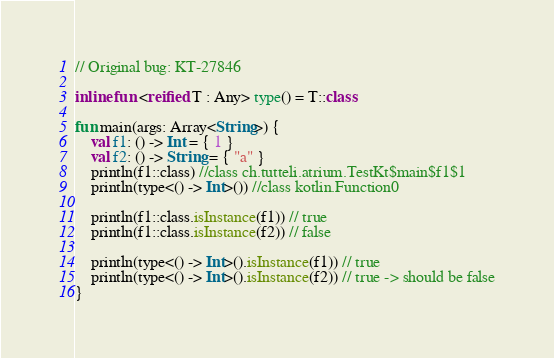Convert code to text. <code><loc_0><loc_0><loc_500><loc_500><_Kotlin_>// Original bug: KT-27846

inline fun <reified T : Any> type() = T::class

fun main(args: Array<String>) {
    val f1: () -> Int = { 1 }
    val f2: () -> String = { "a" }
    println(f1::class) //class ch.tutteli.atrium.TestKt$main$f1$1
    println(type<() -> Int>()) //class kotlin.Function0

    println(f1::class.isInstance(f1)) // true
    println(f1::class.isInstance(f2)) // false

    println(type<() -> Int>().isInstance(f1)) // true
    println(type<() -> Int>().isInstance(f2)) // true -> should be false
}
</code> 